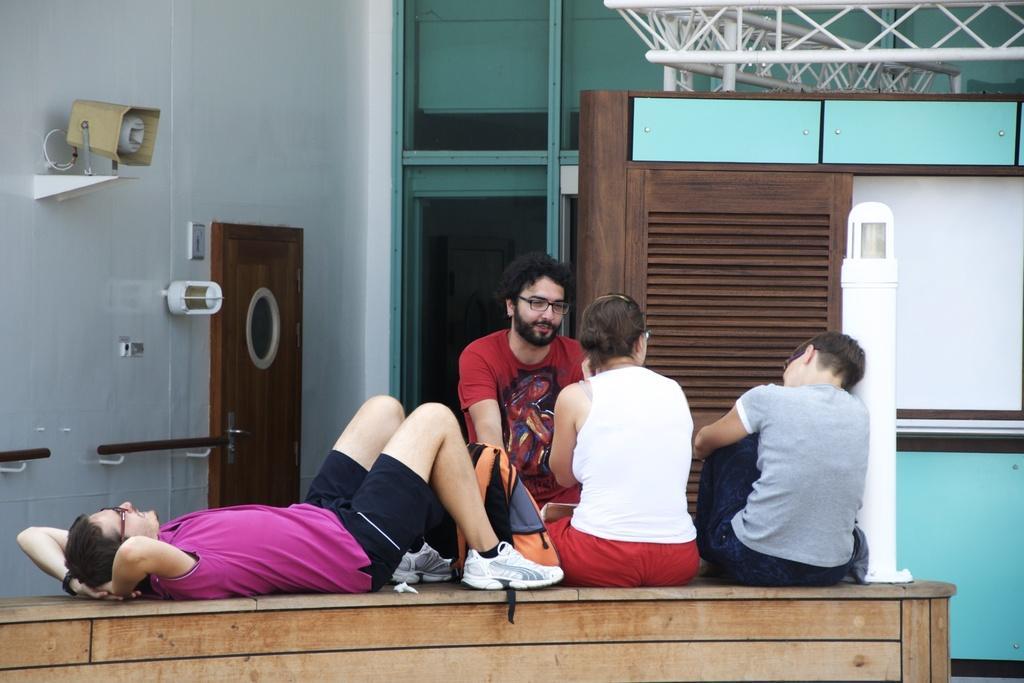Describe this image in one or two sentences. In this image I can see a person lying, wearing a pink t shirt and black shorts. 3 people are sitting. There is a cctv camera and a door on the left. There is a building at the back. 